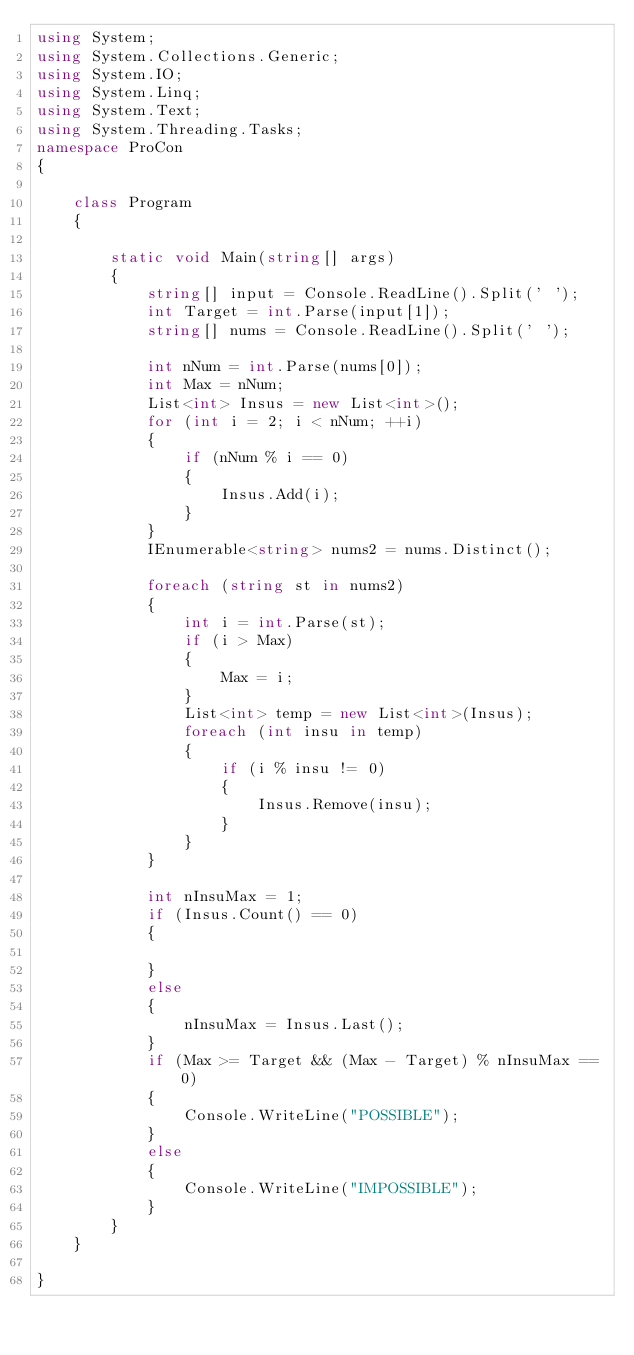Convert code to text. <code><loc_0><loc_0><loc_500><loc_500><_C#_>using System;
using System.Collections.Generic;
using System.IO;
using System.Linq;
using System.Text;
using System.Threading.Tasks;
namespace ProCon
{

    class Program
    {

        static void Main(string[] args)
        {
            string[] input = Console.ReadLine().Split(' ');
            int Target = int.Parse(input[1]);
            string[] nums = Console.ReadLine().Split(' ');

            int nNum = int.Parse(nums[0]);
            int Max = nNum;
            List<int> Insus = new List<int>();
            for (int i = 2; i < nNum; ++i)
            {
                if (nNum % i == 0)
                {
                    Insus.Add(i);
                }
            }
            IEnumerable<string> nums2 = nums.Distinct();

            foreach (string st in nums2)
            {
                int i = int.Parse(st);
                if (i > Max)
                {
                    Max = i;
                }
                List<int> temp = new List<int>(Insus);
                foreach (int insu in temp)
                {
                    if (i % insu != 0)
                    {
                        Insus.Remove(insu);
                    }
                }
            }

            int nInsuMax = 1;
            if (Insus.Count() == 0)
            {

            }
            else
            {
                nInsuMax = Insus.Last();
            }
            if (Max >= Target && (Max - Target) % nInsuMax == 0)
            {
                Console.WriteLine("POSSIBLE");
            }
            else
            {
                Console.WriteLine("IMPOSSIBLE");
            }
        }
    }

}</code> 